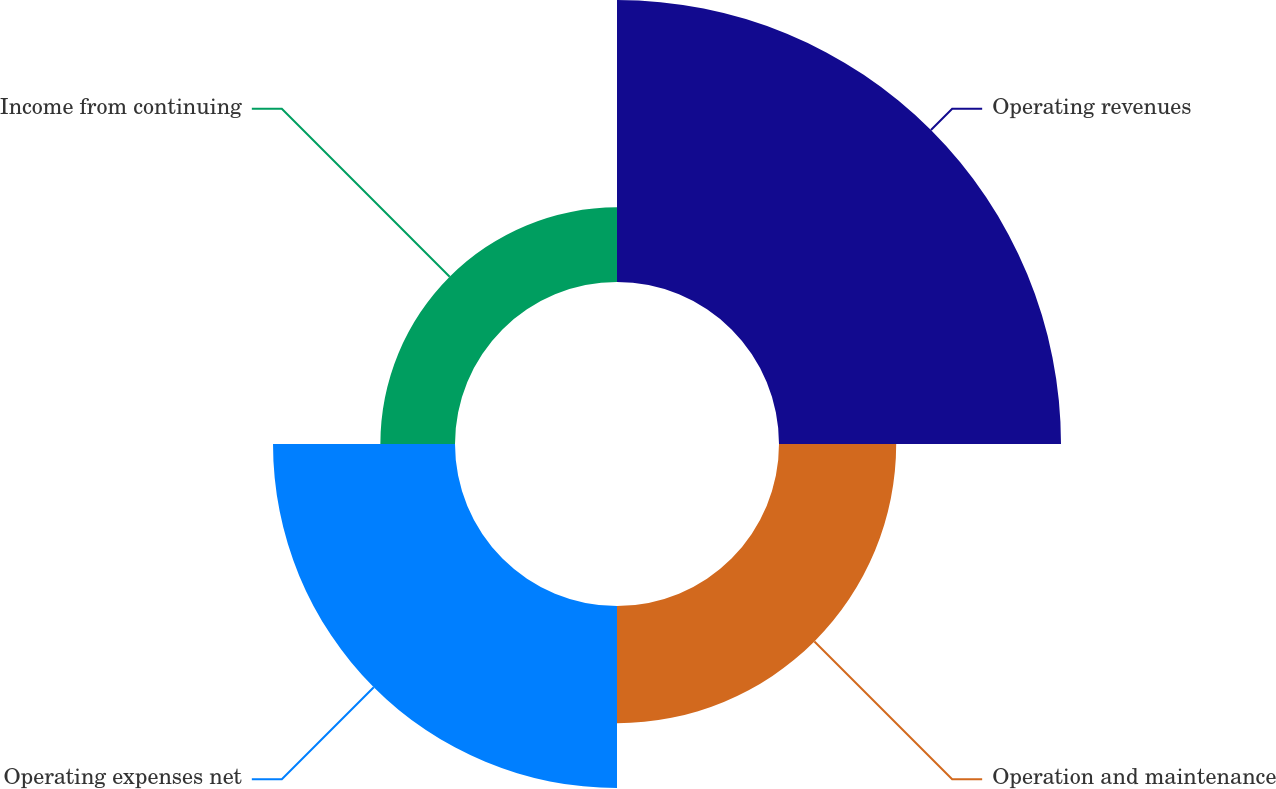Convert chart. <chart><loc_0><loc_0><loc_500><loc_500><pie_chart><fcel>Operating revenues<fcel>Operation and maintenance<fcel>Operating expenses net<fcel>Income from continuing<nl><fcel>43.0%<fcel>17.87%<fcel>27.75%<fcel>11.38%<nl></chart> 